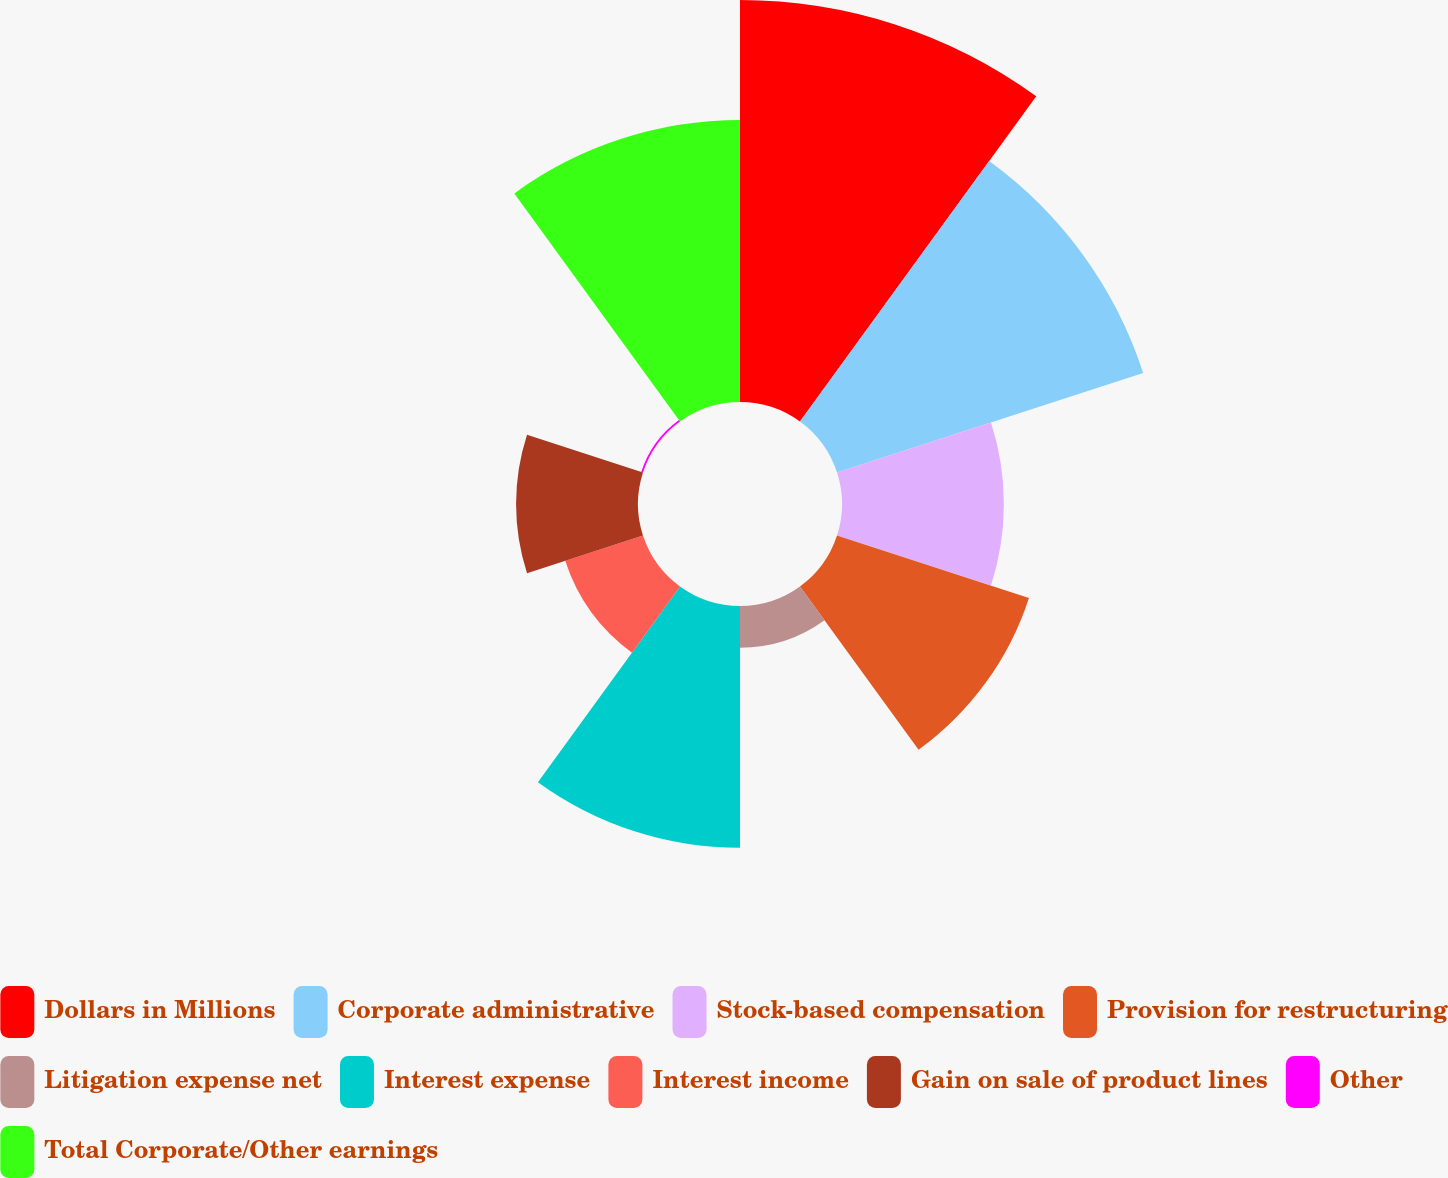Convert chart. <chart><loc_0><loc_0><loc_500><loc_500><pie_chart><fcel>Dollars in Millions<fcel>Corporate administrative<fcel>Stock-based compensation<fcel>Provision for restructuring<fcel>Litigation expense net<fcel>Interest expense<fcel>Interest income<fcel>Gain on sale of product lines<fcel>Other<fcel>Total Corporate/Other earnings<nl><fcel>21.63%<fcel>17.32%<fcel>8.71%<fcel>10.86%<fcel>2.25%<fcel>13.01%<fcel>4.4%<fcel>6.56%<fcel>0.1%<fcel>15.17%<nl></chart> 